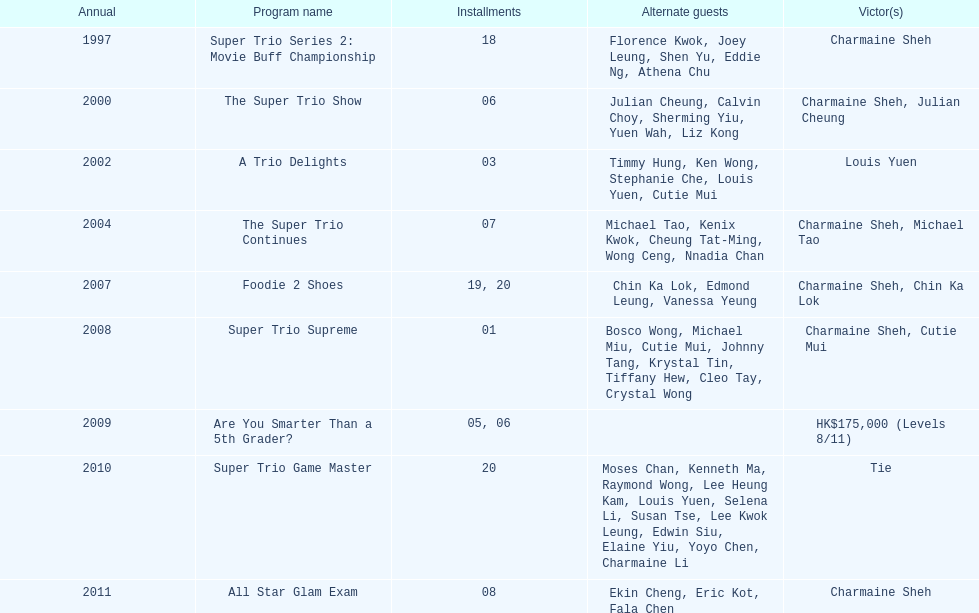How many times has charmaine sheh won on a variety show? 6. 